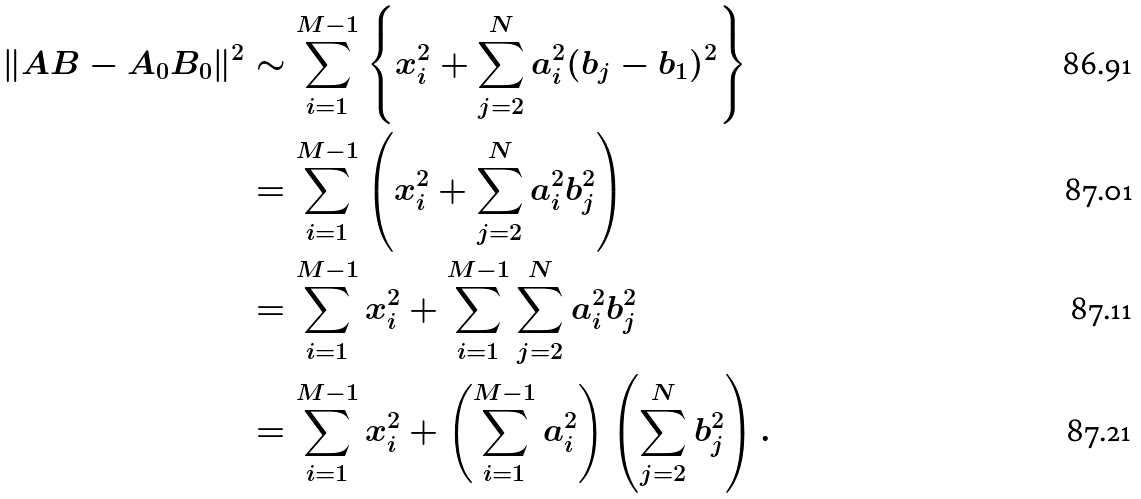Convert formula to latex. <formula><loc_0><loc_0><loc_500><loc_500>\| A B - A _ { 0 } B _ { 0 } \| ^ { 2 } & \sim \sum _ { i = 1 } ^ { M - 1 } \left \{ x _ { i } ^ { 2 } + \sum _ { j = 2 } ^ { N } a _ { i } ^ { 2 } ( b _ { j } - b _ { 1 } ) ^ { 2 } \right \} \\ & = \sum _ { i = 1 } ^ { M - 1 } \left ( x _ { i } ^ { 2 } + \sum _ { j = 2 } ^ { N } a _ { i } ^ { 2 } b _ { j } ^ { 2 } \right ) \\ & = \sum _ { i = 1 } ^ { M - 1 } x _ { i } ^ { 2 } + \sum _ { i = 1 } ^ { M - 1 } \sum _ { j = 2 } ^ { N } a _ { i } ^ { 2 } b _ { j } ^ { 2 } \\ & = \sum _ { i = 1 } ^ { M - 1 } x _ { i } ^ { 2 } + \left ( \sum _ { i = 1 } ^ { M - 1 } a _ { i } ^ { 2 } \right ) \left ( \sum _ { j = 2 } ^ { N } b _ { j } ^ { 2 } \right ) .</formula> 